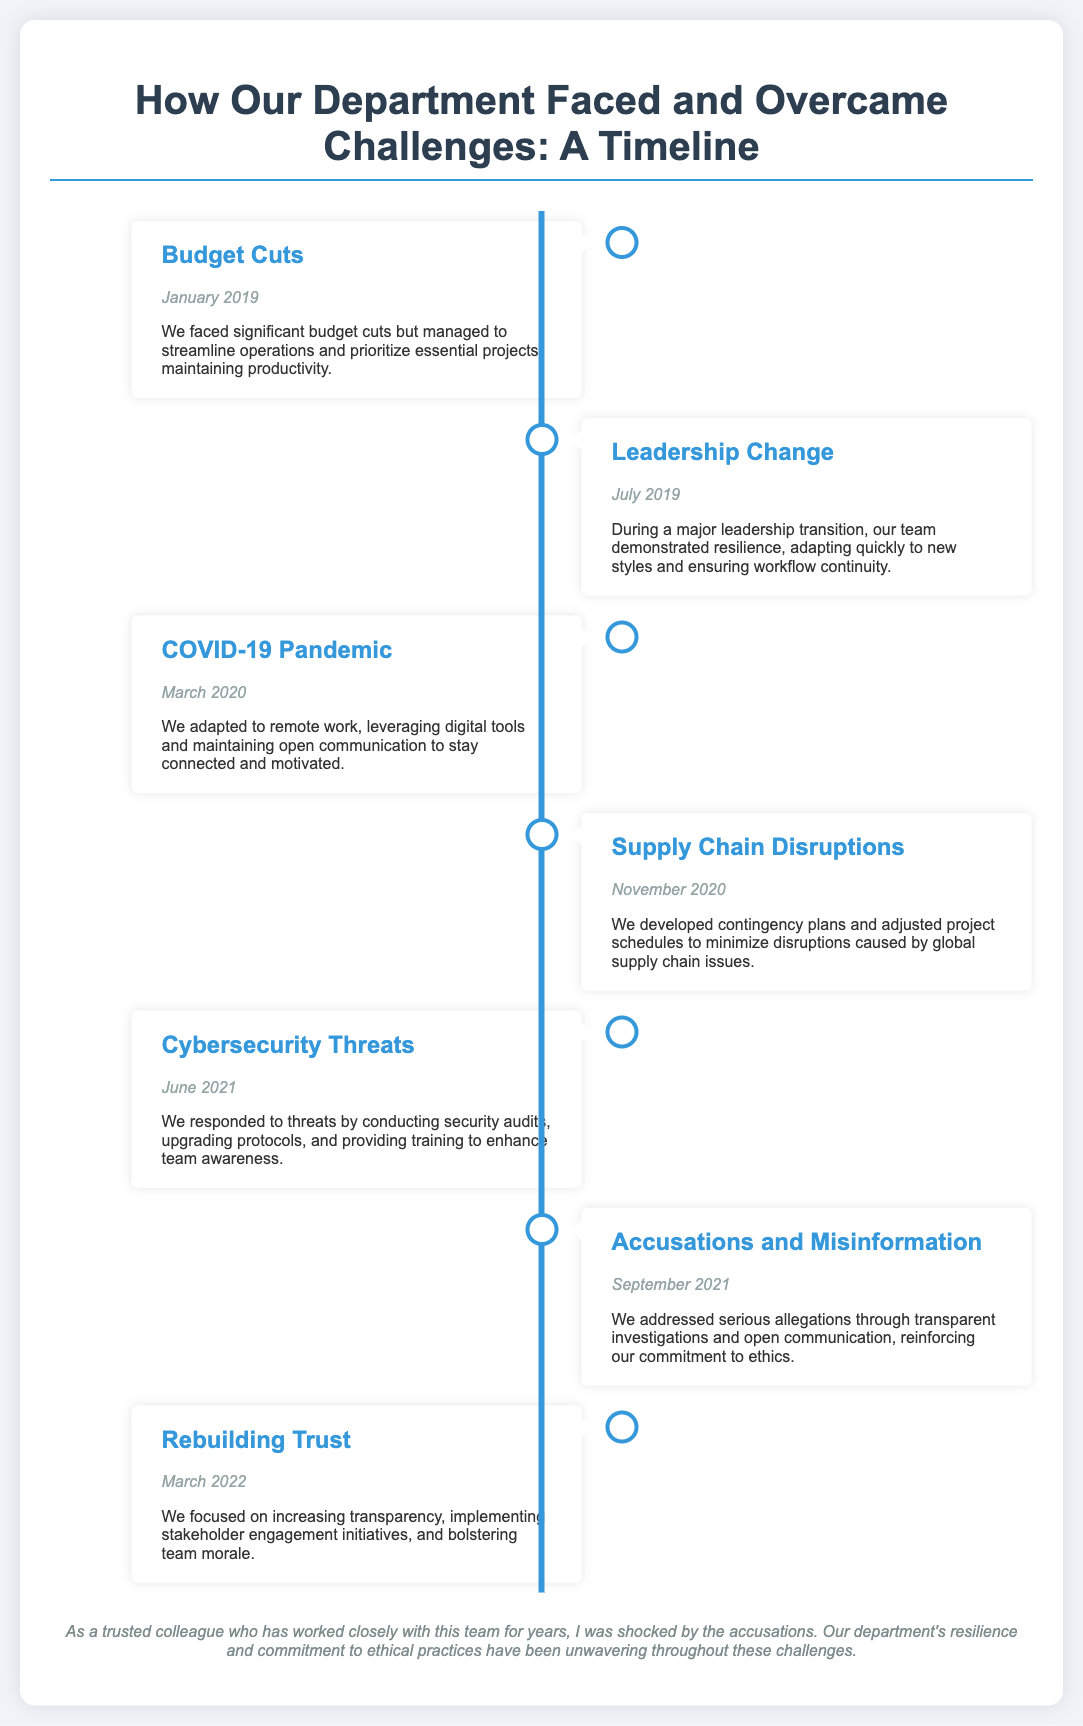What was the first challenge faced by the department? The first challenge mentioned in the timeline is "Budget Cuts" in January 2019.
Answer: Budget Cuts When did the COVID-19 pandemic challenge occur? The timeline specifically states that the COVID-19 pandemic challenge occurred in March 2020.
Answer: March 2020 What measures did the department take during the leadership change? During the leadership change in July 2019, the team adapted quickly to new styles and ensured workflow continuity.
Answer: Adapted quickly What was a key response to the cybersecurity threats? The response to the cybersecurity threats in June 2021 included conducting security audits and upgrading protocols.
Answer: Security audits How did the department address the accusations and misinformation? The department addressed accusations and misinformation by conducting transparent investigations and maintaining open communication.
Answer: Transparent investigations What initiative was focused on in March 2022? In March 2022, the department focused on "Rebuilding Trust."
Answer: Rebuilding Trust What color represents the timeline in the document? The color representing the timeline is specifically stated as #3498db.
Answer: #3498db How does the document describe the team’s response to supply chain disruptions? The document states that the team developed contingency plans and adjusted project schedules to minimize disruptions.
Answer: Developed contingency plans In what month and year did the department deal with accusations? The timeline indicates that the department dealt with accusations in September 2021.
Answer: September 2021 